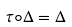<formula> <loc_0><loc_0><loc_500><loc_500>\tau \circ \Delta = \Delta</formula> 